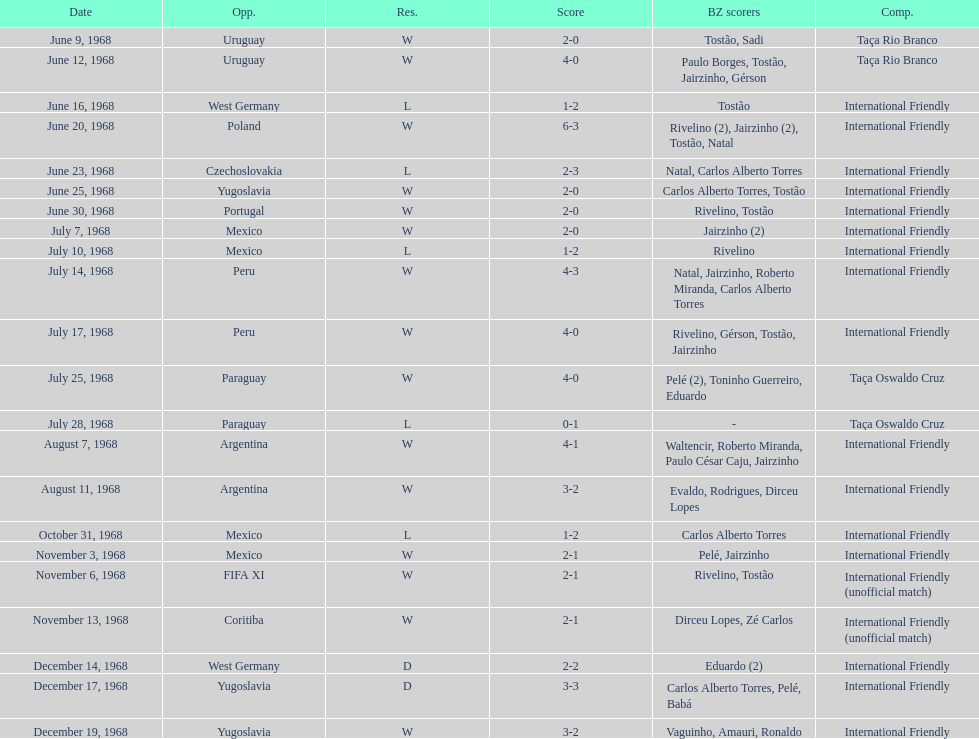How many times did brazil play against argentina in the international friendly competition? 2. 